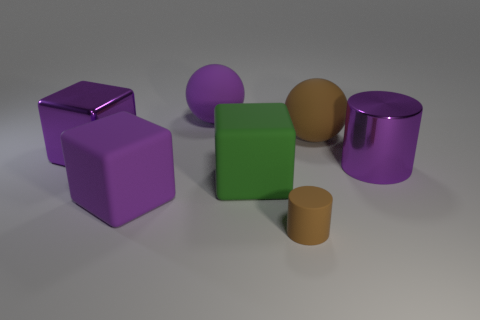Are there any small blue metal cylinders?
Your response must be concise. No. There is a rubber cube on the left side of the big purple rubber sphere; are there any large brown balls on the left side of it?
Offer a very short reply. No. There is another object that is the same shape as the large brown matte object; what is it made of?
Your answer should be compact. Rubber. Is the number of tiny red shiny cylinders greater than the number of things?
Keep it short and to the point. No. Does the big shiny cube have the same color as the large metallic object that is right of the shiny block?
Make the answer very short. Yes. There is a large thing that is to the right of the green matte thing and left of the purple cylinder; what is its color?
Your response must be concise. Brown. How many other things are there of the same material as the small object?
Give a very brief answer. 4. Are there fewer large green matte cubes than large yellow shiny blocks?
Your answer should be very brief. No. Is the material of the green thing the same as the large purple object that is to the right of the big purple rubber ball?
Your response must be concise. No. What shape is the big metal object left of the small rubber object?
Keep it short and to the point. Cube. 